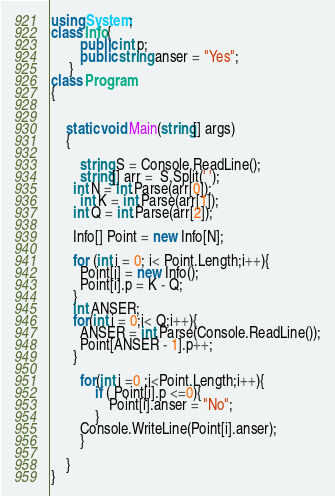<code> <loc_0><loc_0><loc_500><loc_500><_C#_>using System;
class Info{
        public int p;
        public string anser = "Yes"; 
     }
class Program
{
  	
  
	static void Main(string[] args)
	{
      	
		string S = Console.ReadLine();
      	string[] arr =  S.Split(' ');
      int N = int.Parse(arr[0]);
      	int K = int.Parse(arr[1]);
      int Q = int.Parse(arr[2]);
      
      Info[] Point = new Info[N];
      
      for (int i = 0; i< Point.Length;i++){
        Point[i] = new Info();
      	Point[i].p = K - Q;
      }
      int ANSER;
      for(int i = 0;i< Q;i++){
      	ANSER = int.Parse(Console.ReadLine());
        Point[ANSER - 1].p++;
      }
      
      	for(int i =0 ;i<Point.Length;i++){
          	if ( Point[i].p <=0){
            	Point[i].anser = "No";
            }
      	Console.WriteLine(Point[i].anser);
        }

	}
}

</code> 